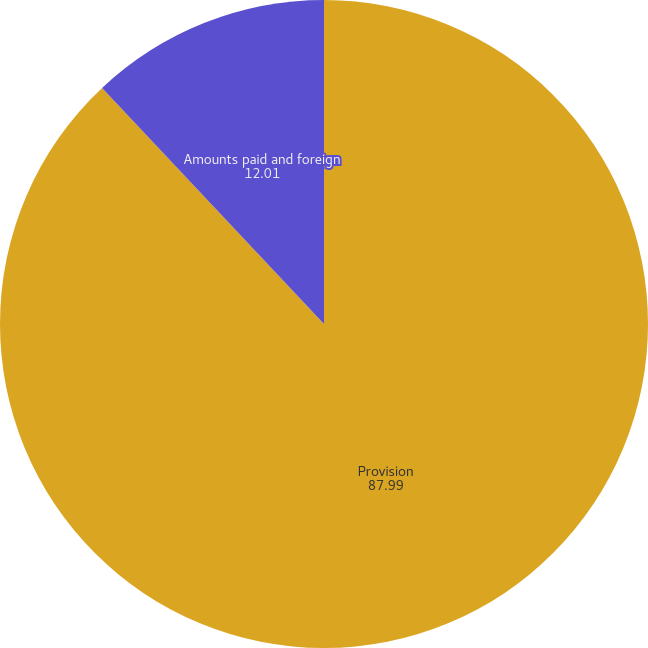Convert chart. <chart><loc_0><loc_0><loc_500><loc_500><pie_chart><fcel>Provision<fcel>Amounts paid and foreign<nl><fcel>87.99%<fcel>12.01%<nl></chart> 